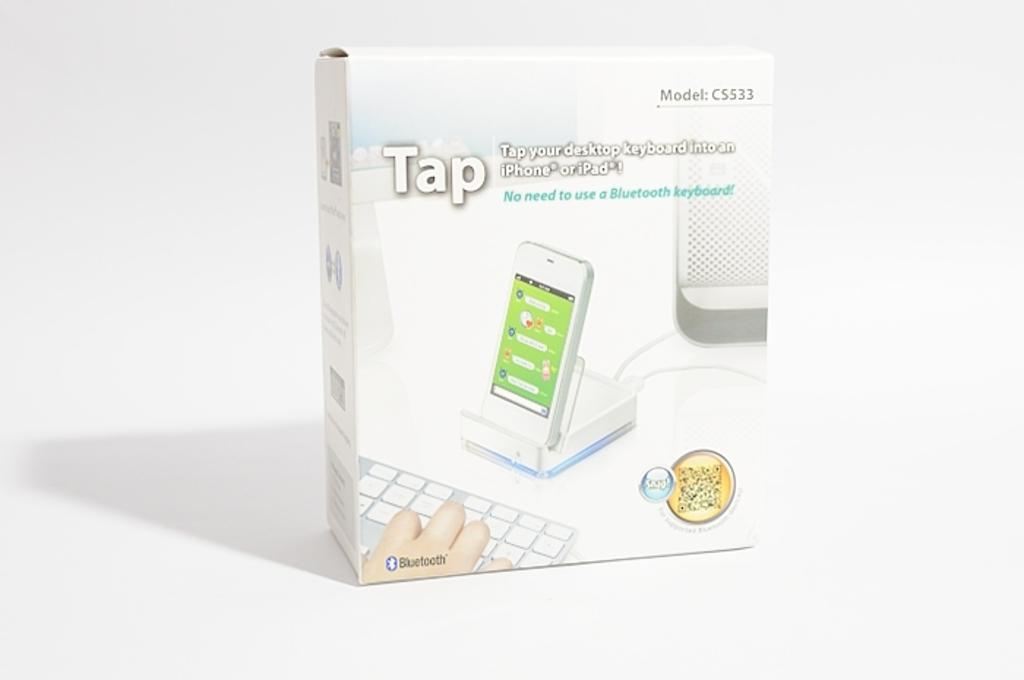Provide a one-sentence caption for the provided image. The box shows a computer tied to a phone and keyboard that is sold by Tap. 